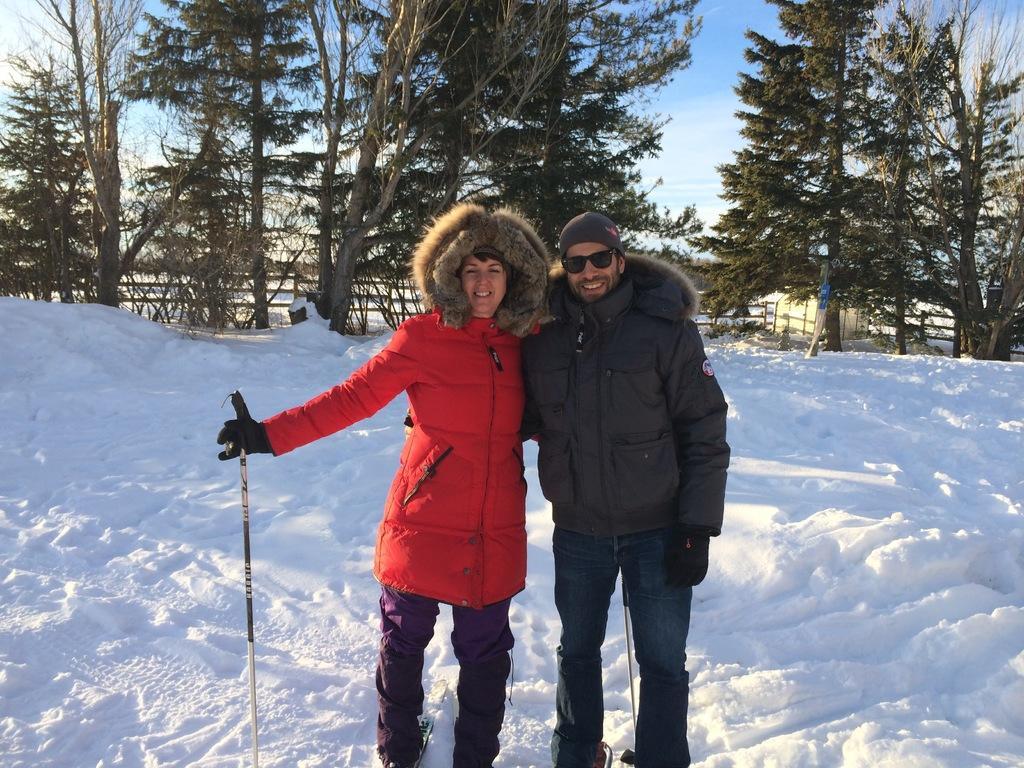Can you describe this image briefly? A lady with red jacket is standing on the snow and holding a stick in her hand. Beside her there is a man with black jacket. He is standing and he is wearing goggles. There is a snow on which they are standing. In the background there are many trees. 